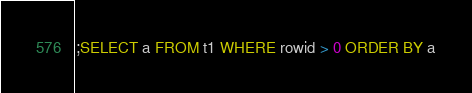<code> <loc_0><loc_0><loc_500><loc_500><_SQL_>;SELECT a FROM t1 WHERE rowid > 0 ORDER BY a</code> 